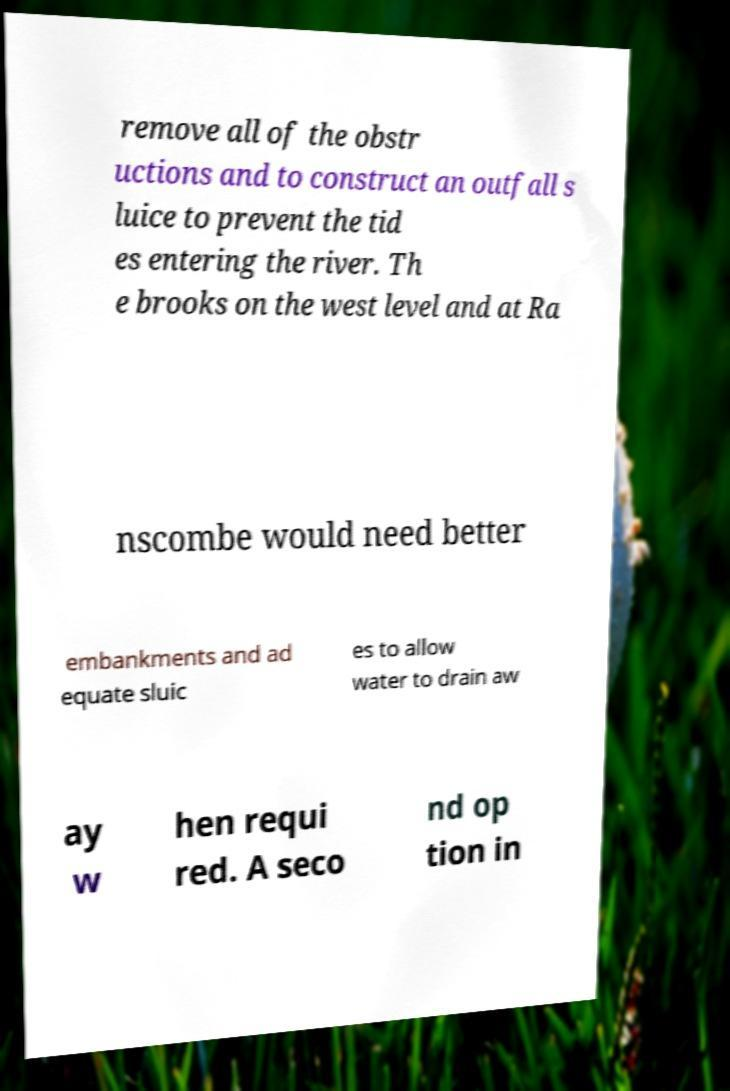For documentation purposes, I need the text within this image transcribed. Could you provide that? remove all of the obstr uctions and to construct an outfall s luice to prevent the tid es entering the river. Th e brooks on the west level and at Ra nscombe would need better embankments and ad equate sluic es to allow water to drain aw ay w hen requi red. A seco nd op tion in 